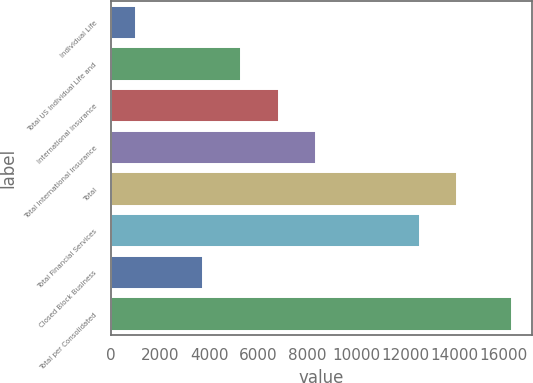Convert chart to OTSL. <chart><loc_0><loc_0><loc_500><loc_500><bar_chart><fcel>Individual Life<fcel>Total US Individual Life and<fcel>International Insurance<fcel>Total International Insurance<fcel>Total<fcel>Total Financial Services<fcel>Closed Block Business<fcel>Total per Consolidated<nl><fcel>1007<fcel>5295.9<fcel>6829.8<fcel>8363.7<fcel>14117.9<fcel>12584<fcel>3762<fcel>16346<nl></chart> 